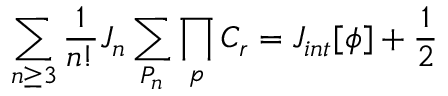Convert formula to latex. <formula><loc_0><loc_0><loc_500><loc_500>\sum _ { n \geq 3 } { \frac { 1 } n ! } } J _ { n } \sum _ { P _ { n } } \prod _ { p } C _ { r } = J _ { i n t } [ \phi ] + { \frac { 1 } { 2 } }</formula> 